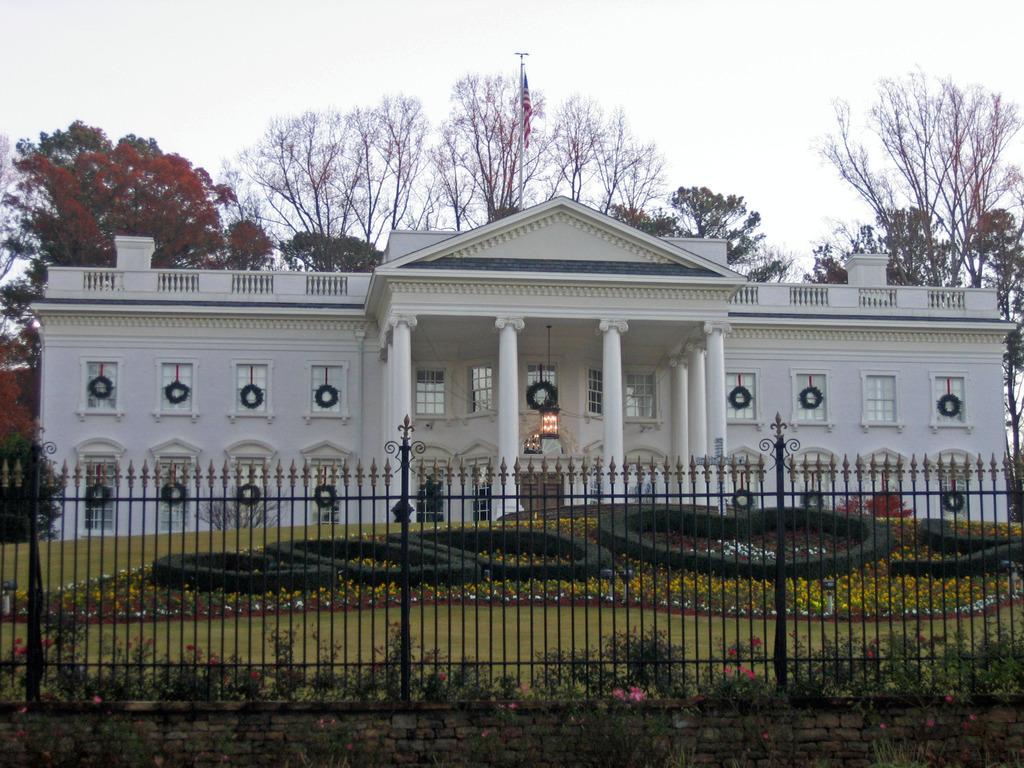In one or two sentences, can you explain what this image depicts? In this image, we can see a white building, walls, windows, pillars, few decorative objects, railings. At the bottom, we can see grills, brick wall, plants, grass, flowers. Background we can see trees, pole, flag and sky. 